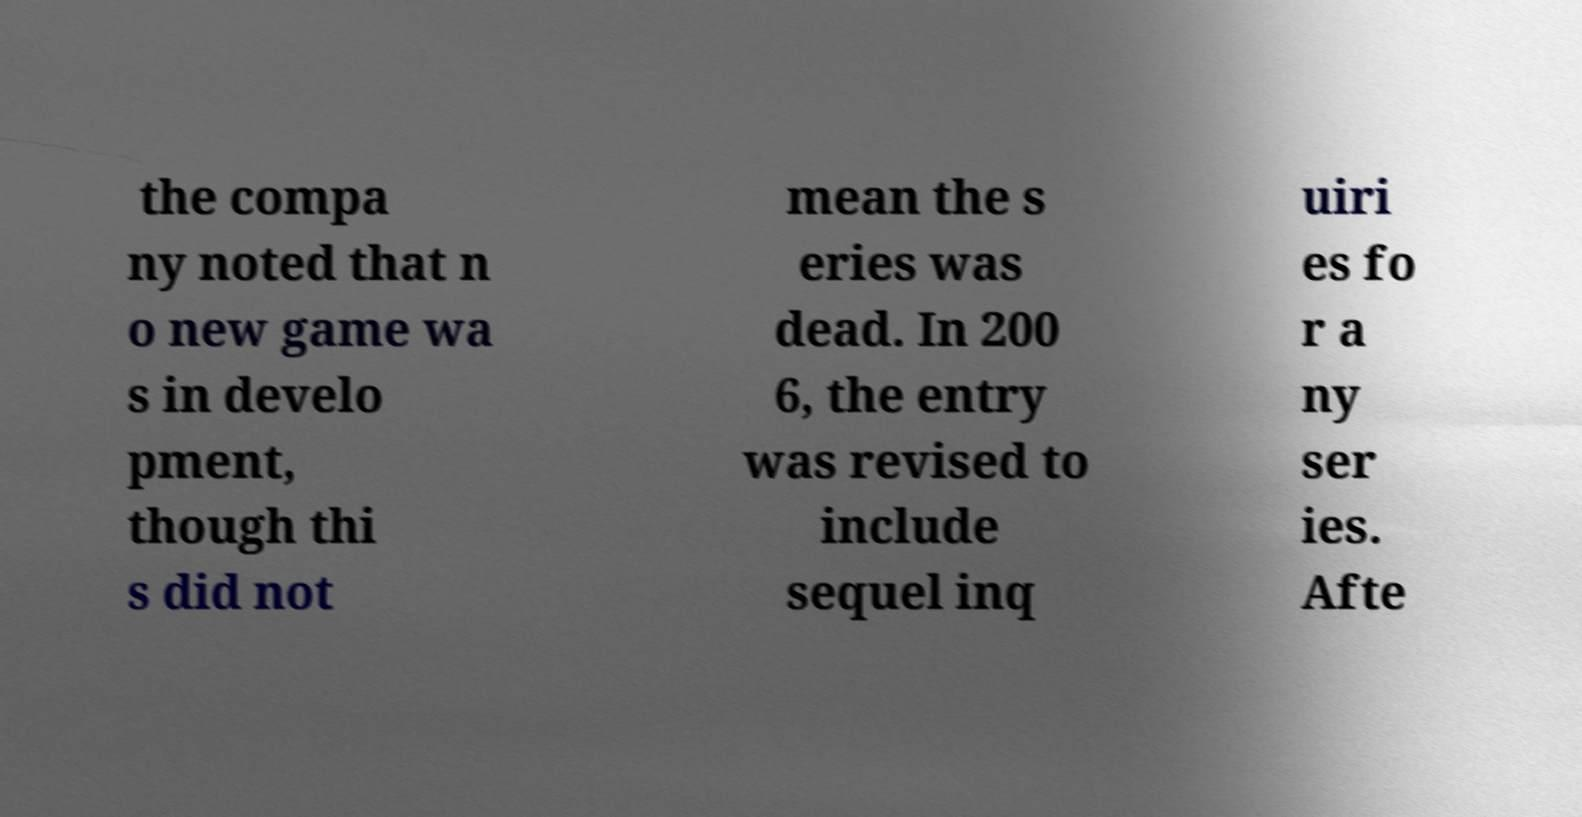For documentation purposes, I need the text within this image transcribed. Could you provide that? the compa ny noted that n o new game wa s in develo pment, though thi s did not mean the s eries was dead. In 200 6, the entry was revised to include sequel inq uiri es fo r a ny ser ies. Afte 